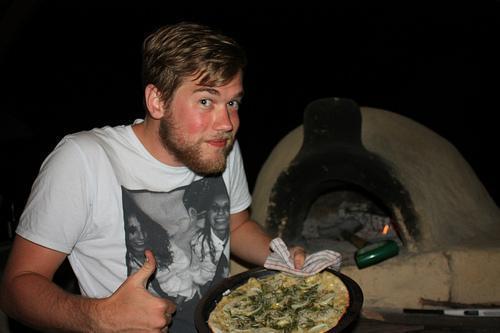How many people are in this photo?
Give a very brief answer. 1. 